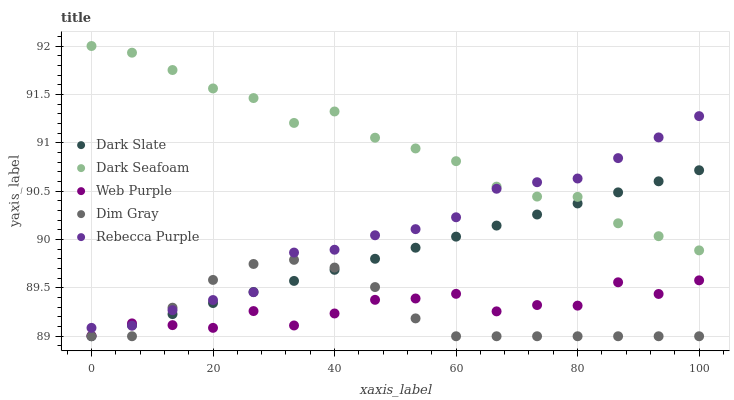Does Dim Gray have the minimum area under the curve?
Answer yes or no. Yes. Does Dark Seafoam have the maximum area under the curve?
Answer yes or no. Yes. Does Dark Seafoam have the minimum area under the curve?
Answer yes or no. No. Does Dim Gray have the maximum area under the curve?
Answer yes or no. No. Is Dark Slate the smoothest?
Answer yes or no. Yes. Is Web Purple the roughest?
Answer yes or no. Yes. Is Dark Seafoam the smoothest?
Answer yes or no. No. Is Dark Seafoam the roughest?
Answer yes or no. No. Does Dark Slate have the lowest value?
Answer yes or no. Yes. Does Dark Seafoam have the lowest value?
Answer yes or no. No. Does Dark Seafoam have the highest value?
Answer yes or no. Yes. Does Dim Gray have the highest value?
Answer yes or no. No. Is Dim Gray less than Dark Seafoam?
Answer yes or no. Yes. Is Dark Seafoam greater than Dim Gray?
Answer yes or no. Yes. Does Dark Seafoam intersect Dark Slate?
Answer yes or no. Yes. Is Dark Seafoam less than Dark Slate?
Answer yes or no. No. Is Dark Seafoam greater than Dark Slate?
Answer yes or no. No. Does Dim Gray intersect Dark Seafoam?
Answer yes or no. No. 